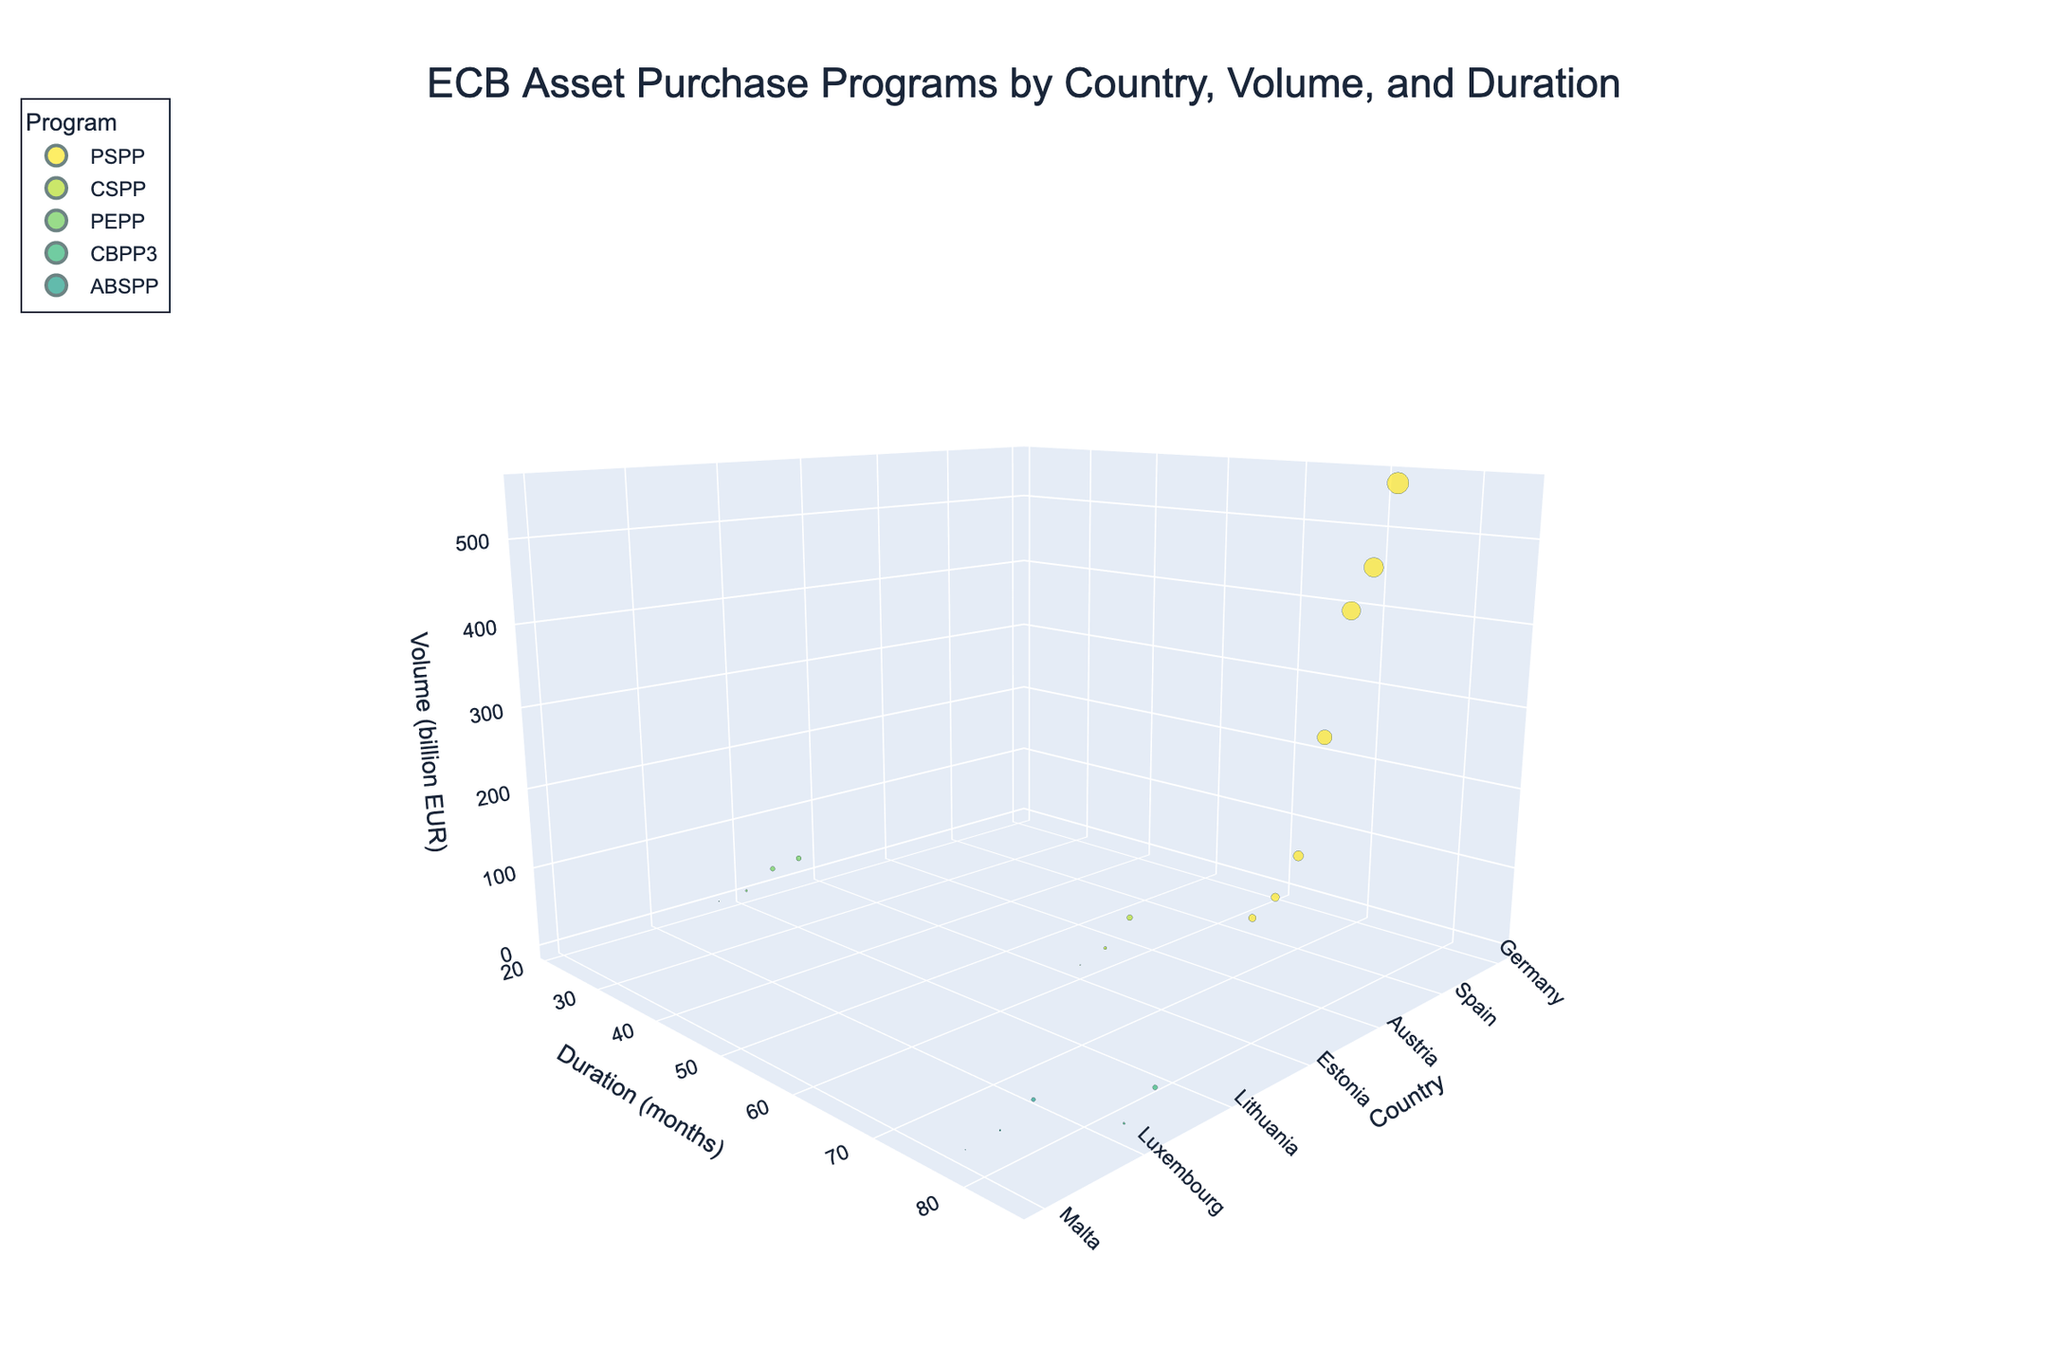Which country has the highest volume in the PSPP program? To determine this, look at the 3D bubble chart and locate bubbles colored for the PSPP program. The largest bubble among these is for Germany, with a volume of 556.8 billion EUR.
Answer: Germany What is the total duration of asset purchase programs in Ireland? Identify the bubble for Ireland on the chart, and refer to the 'Duration (months)' axis. Ireland participates in the CBPP3 program, which has a duration of 84 months.
Answer: 84 months Which program has the shortest duration, and what is it? Observe the bubbles' positions along the 'Duration (months)' axis. The shortest duration is 21 months. This duration corresponds to the bubbles for Finland, Greece, Lithuania, and Cyprus, and the program is PEPP.
Answer: PEPP Compare the volume of the CSPP program between Portugal and Slovenia. Which country has a higher volume and by how much? Identify the bubbles for Portugal and Slovenia in the CSPP program by looking at their positions and colors. Portugal has a volume of 37.5 billion EUR, while Slovenia has a volume of 10.2 billion EUR. The difference is 37.5 - 10.2 = 27.3 billion EUR.
Answer: Portugal, 27.3 billion EUR Which country participates in the most programs based on the visual representation? Count the number of bubbles for each country. The country associated with the most bubbles represents participation in the most programs. This visual observation indicates that Cyprus appears in multiple programs.
Answer: Cyprus How does the duration of Italy's PSPP program compare to the average duration of all programs? First, note that Italy's PSPP program duration is 72 months. Next, calculate the average duration of all programs by summing all durations and dividing by the number of programs: (72 + 72 + 72 + 72 + 72 + 72 + 72 + 60 + 21 + 84 + 21 + 78 + 60 + 84 + 21 + 78 + 60 + 21 + 78) / 19. The total is 1054; the average is 1054 / 19 ≈ 55.5 months. Italy's PSPP program duration is longer than this average.
Answer: Longer What is the smallest volume observed in the data and which country does it pertain to? Examine the smallest bubbles in the 3D chart to identify the smallest volume. The smallest volume is 0.3 billion EUR for Malta within the ABSPP program.
Answer: 0.3 billion EUR, Malta Considering the PEPP program, what is the combined volume for Lithuania and Cyprus? Find the bubbles for Lithuania and Cyprus in the PEPP program, and sum their volumes. Lithuania has 4.8 billion EUR and Cyprus has 0.7 billion EUR. The combined volume is 4.8 + 0.7 = 5.5 billion EUR.
Answer: 5.5 billion EUR What is the range of durations for all the programs shown in the chart? Identify the minimum and maximum values along the 'Duration (months)' axis. The shortest duration is 21 months, and the longest is 84 months. The range is 84 - 21 = 63 months.
Answer: 63 months 